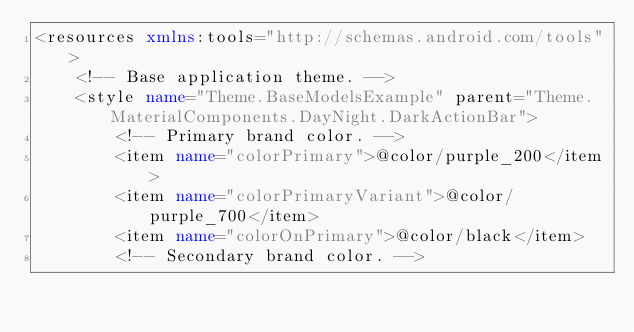Convert code to text. <code><loc_0><loc_0><loc_500><loc_500><_XML_><resources xmlns:tools="http://schemas.android.com/tools">
    <!-- Base application theme. -->
    <style name="Theme.BaseModelsExample" parent="Theme.MaterialComponents.DayNight.DarkActionBar">
        <!-- Primary brand color. -->
        <item name="colorPrimary">@color/purple_200</item>
        <item name="colorPrimaryVariant">@color/purple_700</item>
        <item name="colorOnPrimary">@color/black</item>
        <!-- Secondary brand color. --></code> 